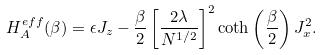Convert formula to latex. <formula><loc_0><loc_0><loc_500><loc_500>H ^ { e f f } _ { A } ( \beta ) = \epsilon J _ { z } - \frac { \beta } { 2 } \left [ \frac { 2 \lambda } { N ^ { 1 / 2 } } \right ] ^ { 2 } \coth \left ( \frac { \beta } { 2 } \right ) J _ { x } ^ { 2 } .</formula> 